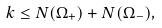Convert formula to latex. <formula><loc_0><loc_0><loc_500><loc_500>k \leq N ( \Omega _ { + } ) + N ( \Omega _ { - } ) ,</formula> 